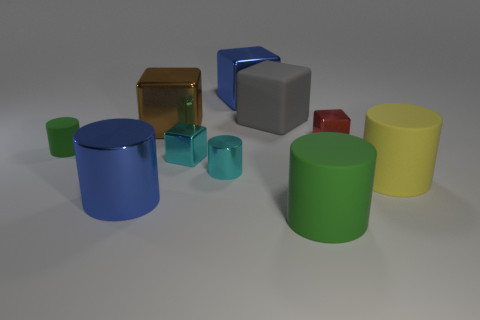There is a matte cylinder that is on the left side of the tiny red metallic thing and on the right side of the tiny green matte thing; what is its color?
Offer a terse response. Green. There is a big blue thing to the right of the large brown shiny cube; what material is it?
Provide a short and direct response. Metal. The cyan metallic cube is what size?
Keep it short and to the point. Small. What number of yellow things are small objects or large matte cubes?
Your answer should be very brief. 0. There is a green object that is right of the green thing to the left of the big brown thing; what size is it?
Keep it short and to the point. Large. There is a matte cube; is it the same color as the large thing right of the red shiny object?
Give a very brief answer. No. What number of other objects are the same material as the big yellow object?
Keep it short and to the point. 3. Are there the same number of big gray matte objects and large rubber cylinders?
Ensure brevity in your answer.  No. The tiny red object that is the same material as the brown object is what shape?
Make the answer very short. Cube. Are there any other things of the same color as the large shiny cylinder?
Provide a succinct answer. Yes. 